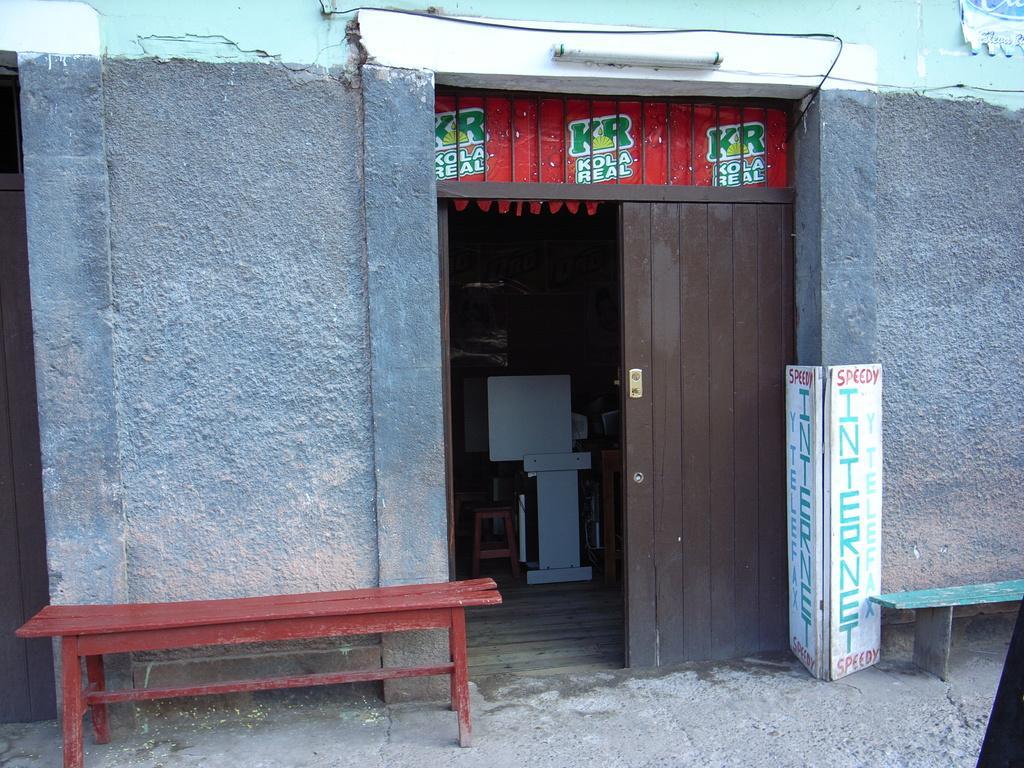How would you summarize this image in a sentence or two? Here I can see a wall along with the doors. In front of the wall there are two benches and a board. In the inside I can see a table, chair and some other objects in the dark. 